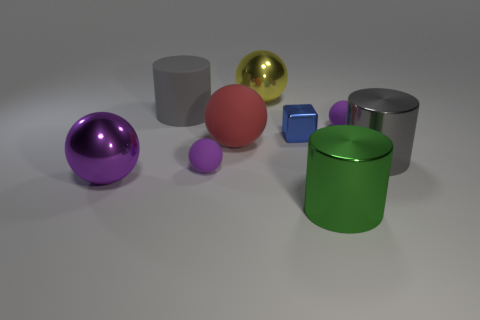Are there more purple metallic balls behind the big purple metal object than gray cylinders that are on the left side of the small shiny object?
Make the answer very short. No. What number of other things are there of the same size as the purple metal object?
Provide a short and direct response. 5. There is a large metallic cylinder right of the green metal cylinder; does it have the same color as the metal cube?
Keep it short and to the point. No. Are there more green things behind the blue metal object than tiny blue metal balls?
Give a very brief answer. No. Is there anything else that is the same color as the small block?
Your answer should be very brief. No. What is the shape of the tiny thing that is in front of the large matte thing in front of the blue metallic thing?
Offer a very short reply. Sphere. Is the number of red rubber blocks greater than the number of big spheres?
Offer a terse response. No. How many cylinders are both behind the green cylinder and in front of the big gray matte cylinder?
Provide a succinct answer. 1. What number of small matte things are behind the metal sphere that is on the right side of the large purple thing?
Your response must be concise. 0. What number of things are either purple balls to the right of the large green shiny object or tiny matte balls that are in front of the cube?
Offer a very short reply. 2. 